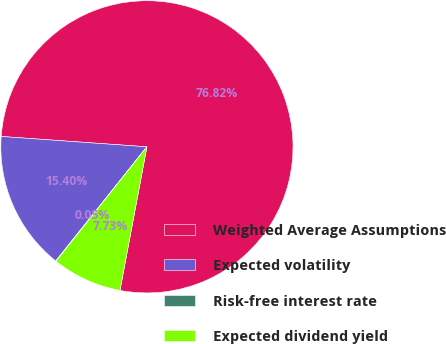Convert chart to OTSL. <chart><loc_0><loc_0><loc_500><loc_500><pie_chart><fcel>Weighted Average Assumptions<fcel>Expected volatility<fcel>Risk-free interest rate<fcel>Expected dividend yield<nl><fcel>76.82%<fcel>15.4%<fcel>0.05%<fcel>7.73%<nl></chart> 